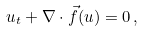<formula> <loc_0><loc_0><loc_500><loc_500>u _ { t } + \nabla \cdot \vec { f } ( u ) = 0 \, ,</formula> 